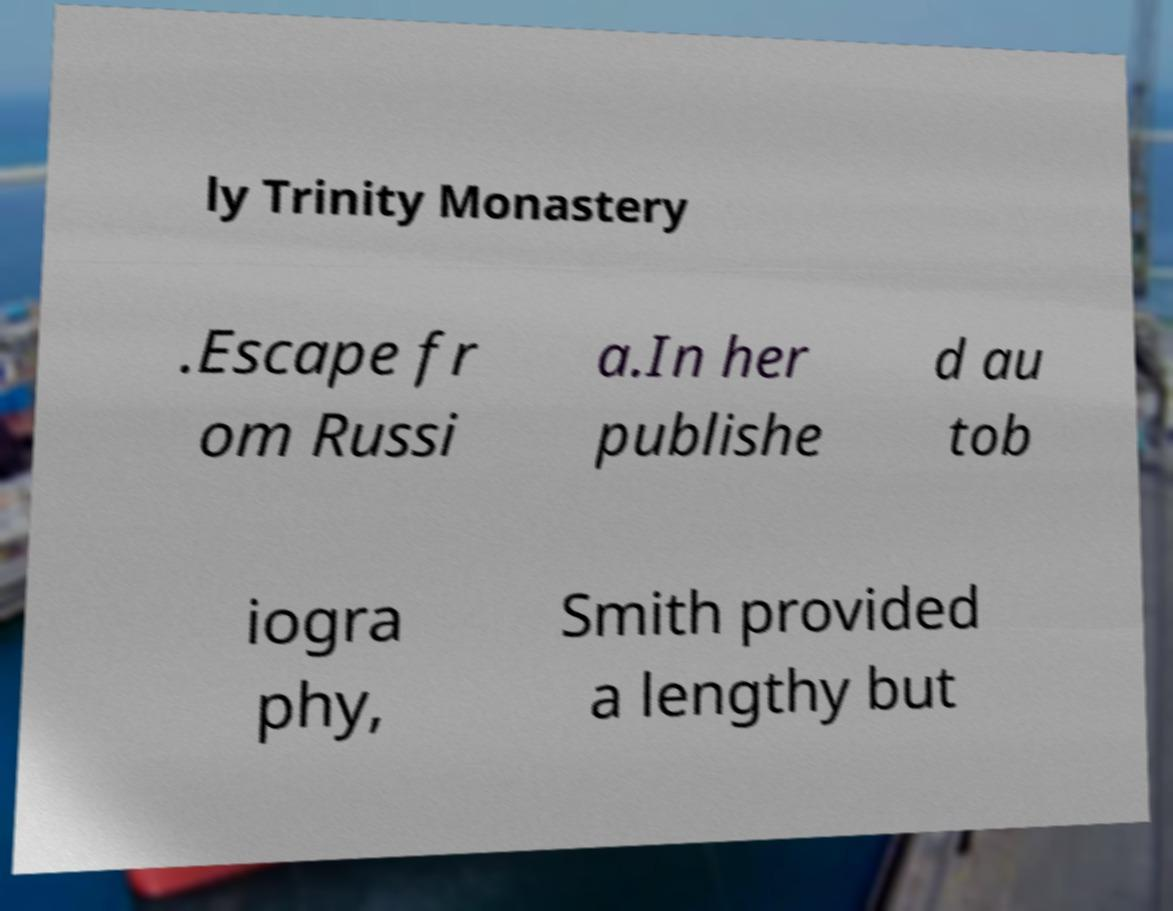I need the written content from this picture converted into text. Can you do that? ly Trinity Monastery .Escape fr om Russi a.In her publishe d au tob iogra phy, Smith provided a lengthy but 